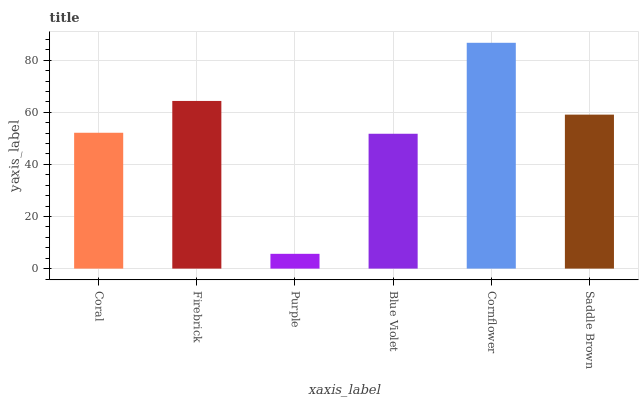Is Purple the minimum?
Answer yes or no. Yes. Is Cornflower the maximum?
Answer yes or no. Yes. Is Firebrick the minimum?
Answer yes or no. No. Is Firebrick the maximum?
Answer yes or no. No. Is Firebrick greater than Coral?
Answer yes or no. Yes. Is Coral less than Firebrick?
Answer yes or no. Yes. Is Coral greater than Firebrick?
Answer yes or no. No. Is Firebrick less than Coral?
Answer yes or no. No. Is Saddle Brown the high median?
Answer yes or no. Yes. Is Coral the low median?
Answer yes or no. Yes. Is Purple the high median?
Answer yes or no. No. Is Purple the low median?
Answer yes or no. No. 